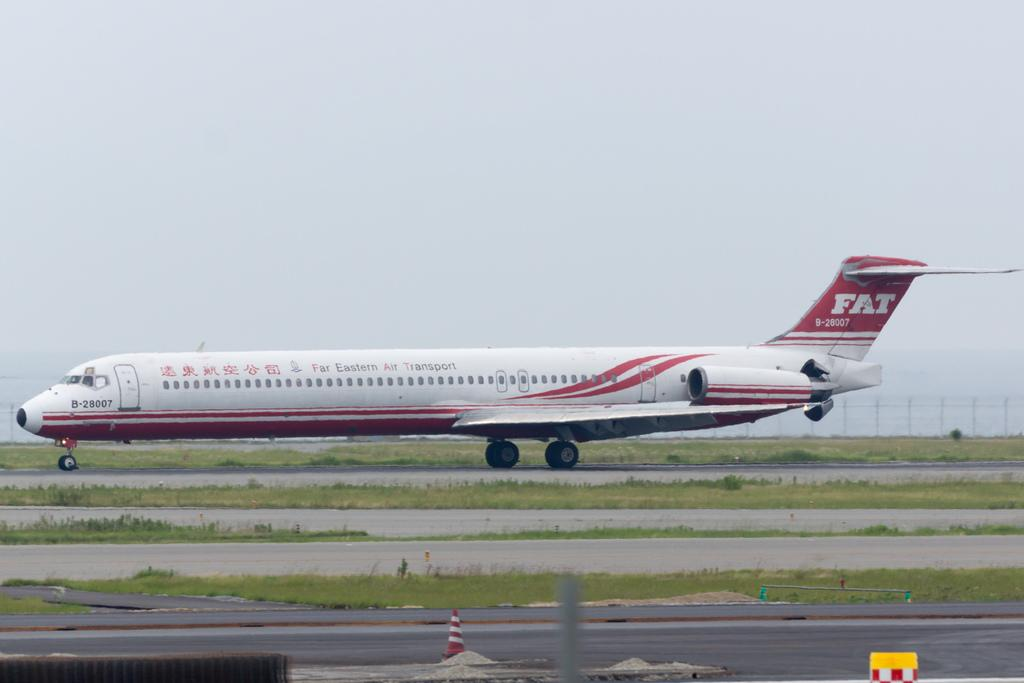Provide a one-sentence caption for the provided image. A Far Eastern Air Transport plane with call sign B-28007. 